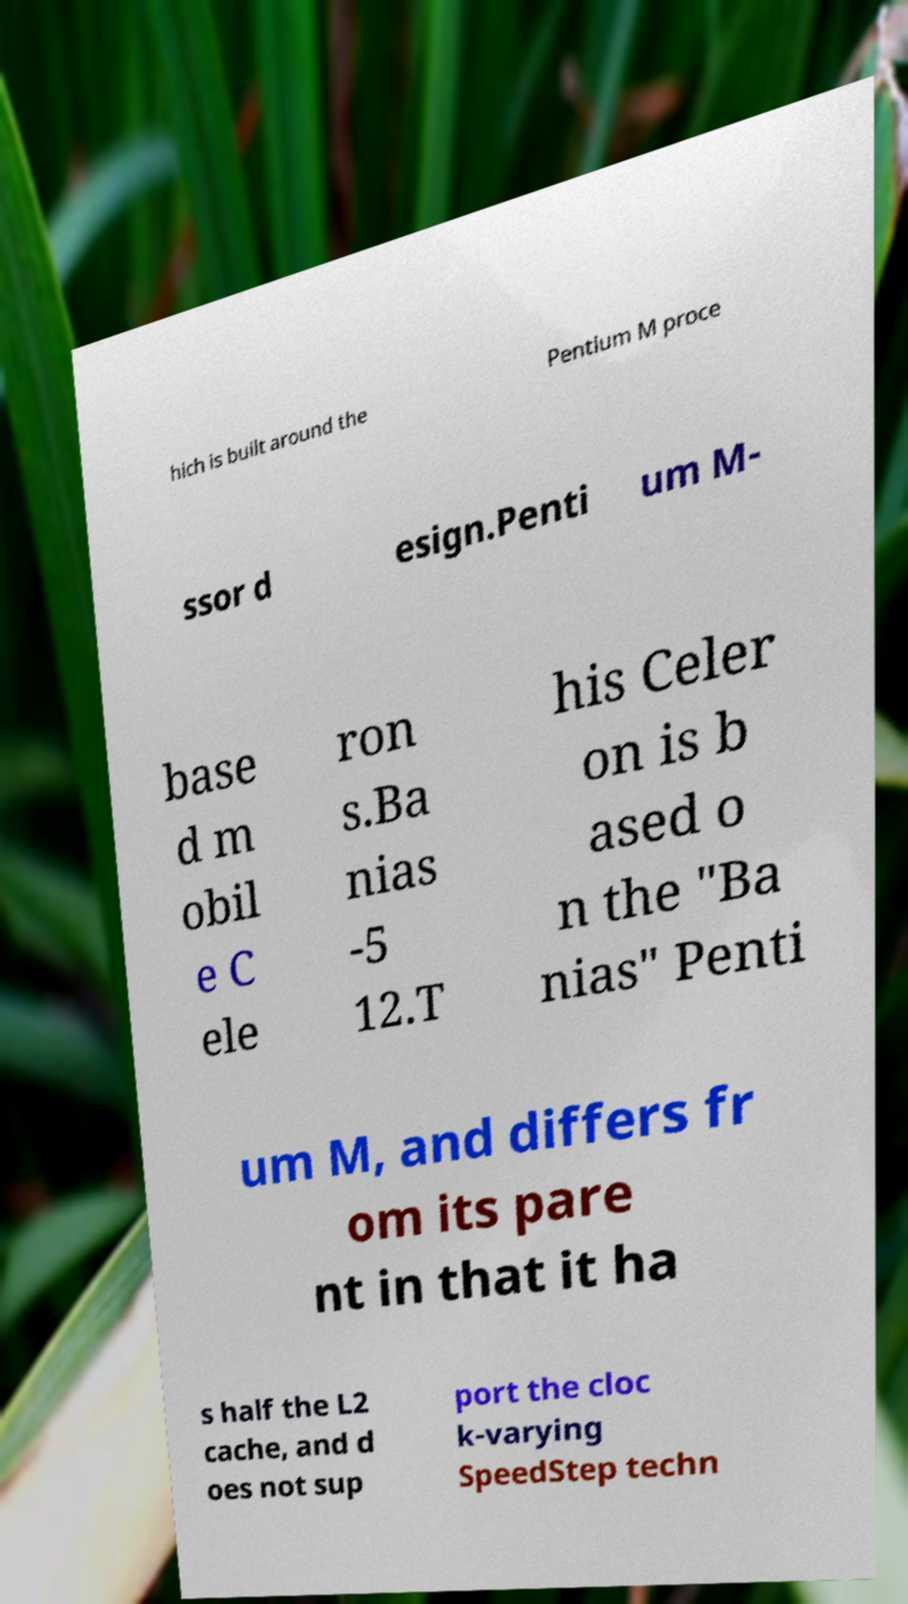Can you accurately transcribe the text from the provided image for me? hich is built around the Pentium M proce ssor d esign.Penti um M- base d m obil e C ele ron s.Ba nias -5 12.T his Celer on is b ased o n the "Ba nias" Penti um M, and differs fr om its pare nt in that it ha s half the L2 cache, and d oes not sup port the cloc k-varying SpeedStep techn 